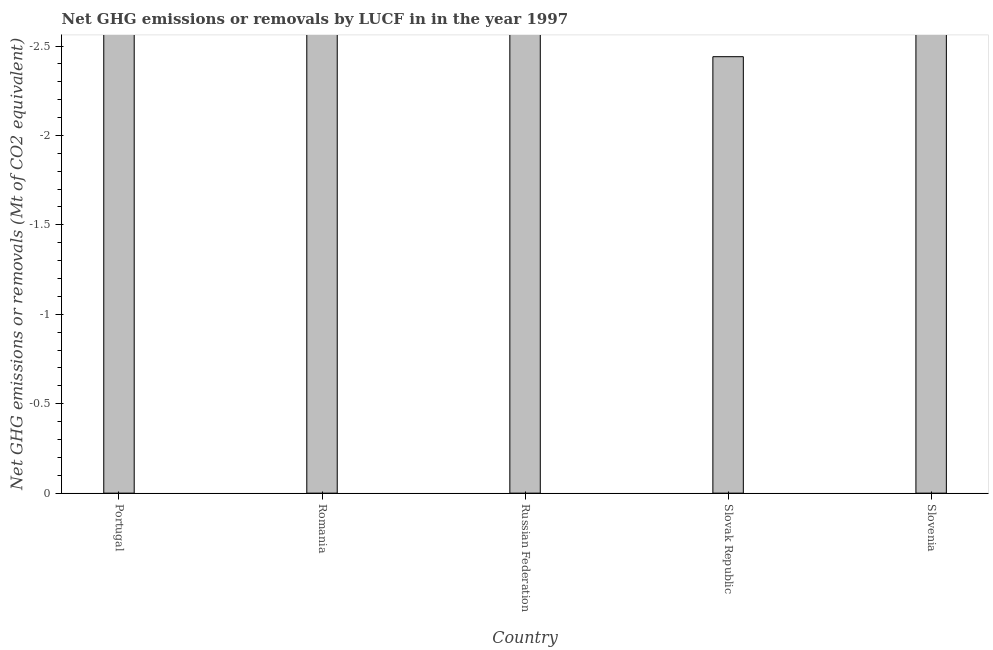Does the graph contain any zero values?
Your response must be concise. Yes. Does the graph contain grids?
Provide a succinct answer. No. What is the title of the graph?
Your answer should be very brief. Net GHG emissions or removals by LUCF in in the year 1997. What is the label or title of the Y-axis?
Your response must be concise. Net GHG emissions or removals (Mt of CO2 equivalent). What is the ghg net emissions or removals in Portugal?
Your answer should be compact. 0. What is the sum of the ghg net emissions or removals?
Your answer should be compact. 0. What is the average ghg net emissions or removals per country?
Your answer should be compact. 0. What is the median ghg net emissions or removals?
Offer a very short reply. 0. In how many countries, is the ghg net emissions or removals greater than -1.8 Mt?
Ensure brevity in your answer.  0. Are all the bars in the graph horizontal?
Keep it short and to the point. No. How many countries are there in the graph?
Ensure brevity in your answer.  5. What is the difference between two consecutive major ticks on the Y-axis?
Offer a very short reply. 0.5. What is the Net GHG emissions or removals (Mt of CO2 equivalent) in Portugal?
Ensure brevity in your answer.  0. What is the Net GHG emissions or removals (Mt of CO2 equivalent) of Romania?
Offer a very short reply. 0. 